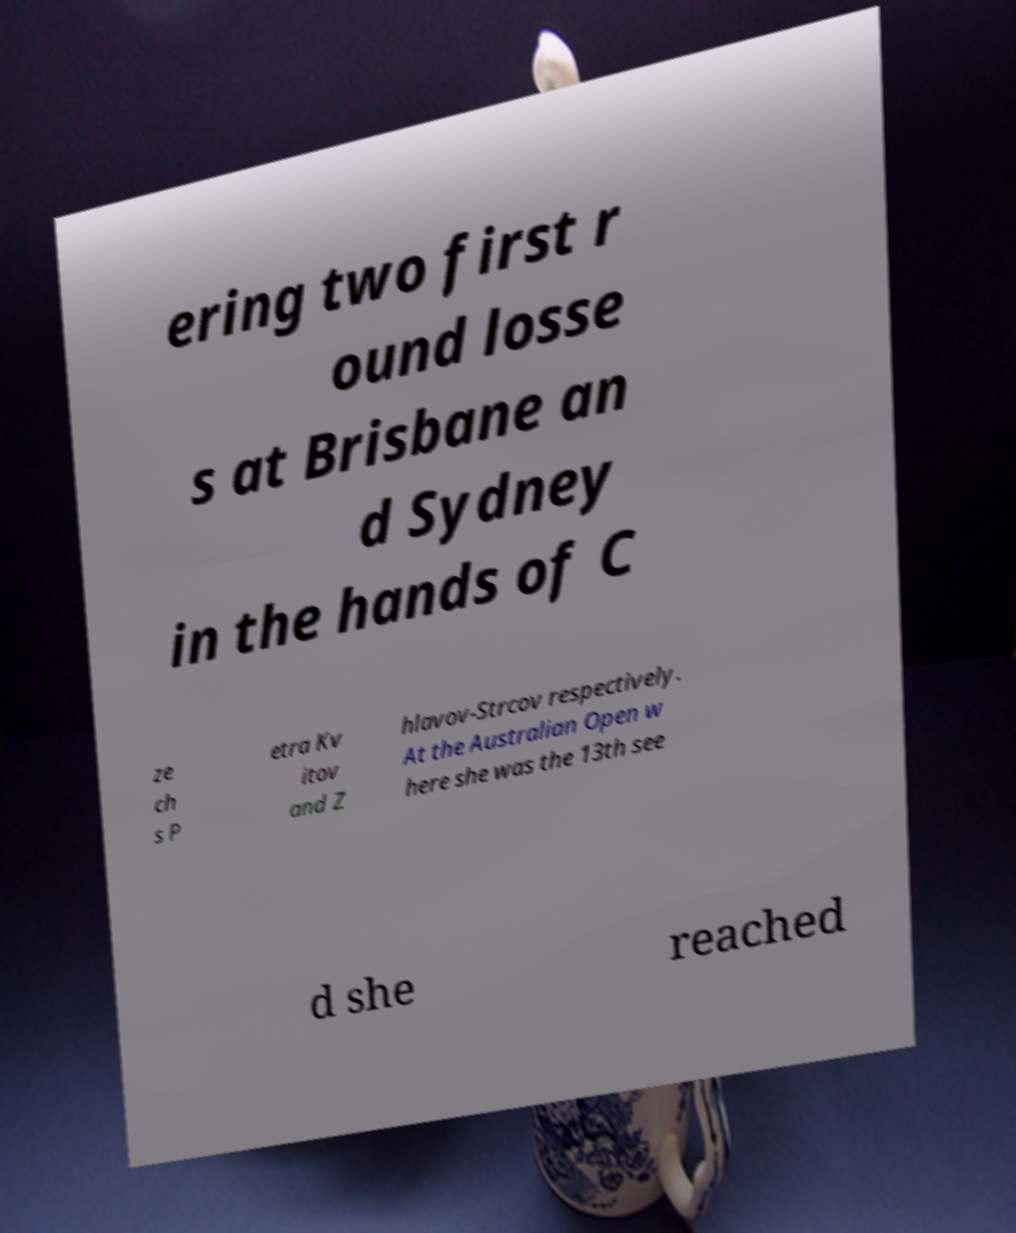For documentation purposes, I need the text within this image transcribed. Could you provide that? ering two first r ound losse s at Brisbane an d Sydney in the hands of C ze ch s P etra Kv itov and Z hlavov-Strcov respectively. At the Australian Open w here she was the 13th see d she reached 